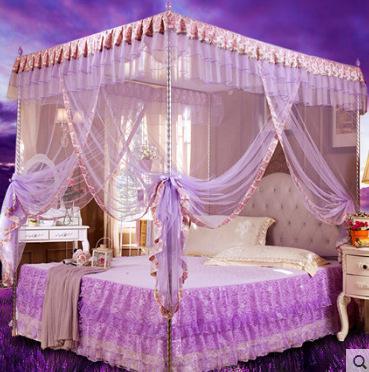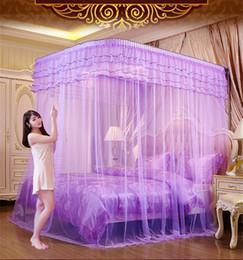The first image is the image on the left, the second image is the image on the right. Considering the images on both sides, is "At least one of the nets is blue." valid? Answer yes or no. No. The first image is the image on the left, the second image is the image on the right. For the images shown, is this caption "There is a square canopy over a mattress on the floor" true? Answer yes or no. No. 